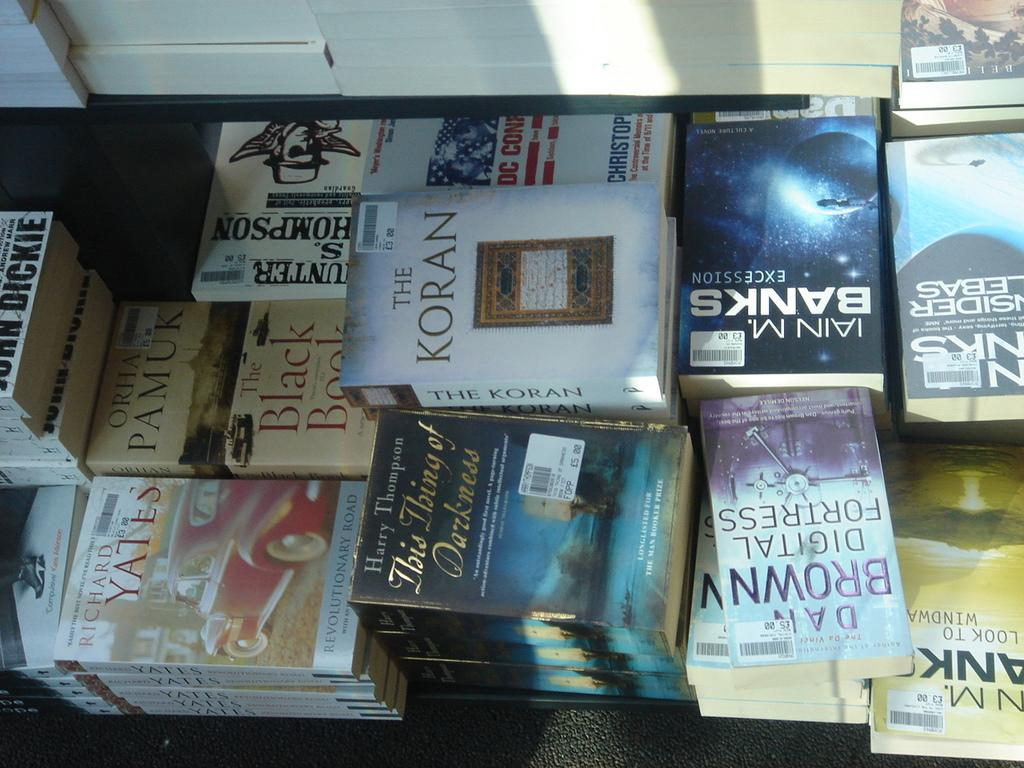Provide a one-sentence caption for the provided image. A bundle of books, one of them being the koran. 